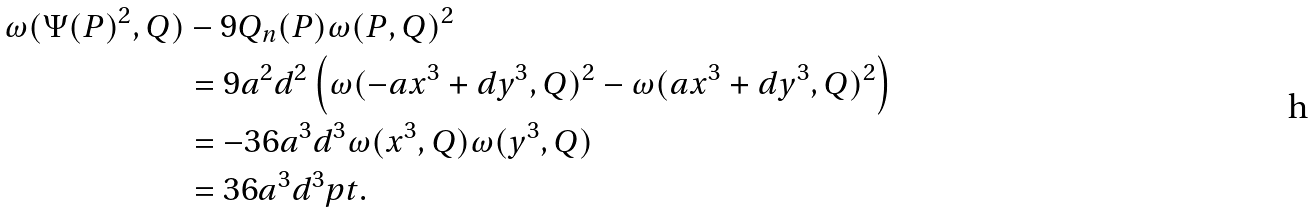<formula> <loc_0><loc_0><loc_500><loc_500>\omega ( \Psi ( P ) ^ { 2 } , Q ) & - 9 Q _ { n } ( P ) \omega ( P , Q ) ^ { 2 } \\ & = 9 a ^ { 2 } d ^ { 2 } \left ( \omega ( - a x ^ { 3 } + d y ^ { 3 } , Q ) ^ { 2 } - \omega ( a x ^ { 3 } + d y ^ { 3 } , Q ) ^ { 2 } \right ) \\ & = - 3 6 a ^ { 3 } d ^ { 3 } \omega ( x ^ { 3 } , Q ) \omega ( y ^ { 3 } , Q ) \\ & = 3 6 a ^ { 3 } d ^ { 3 } p t .</formula> 